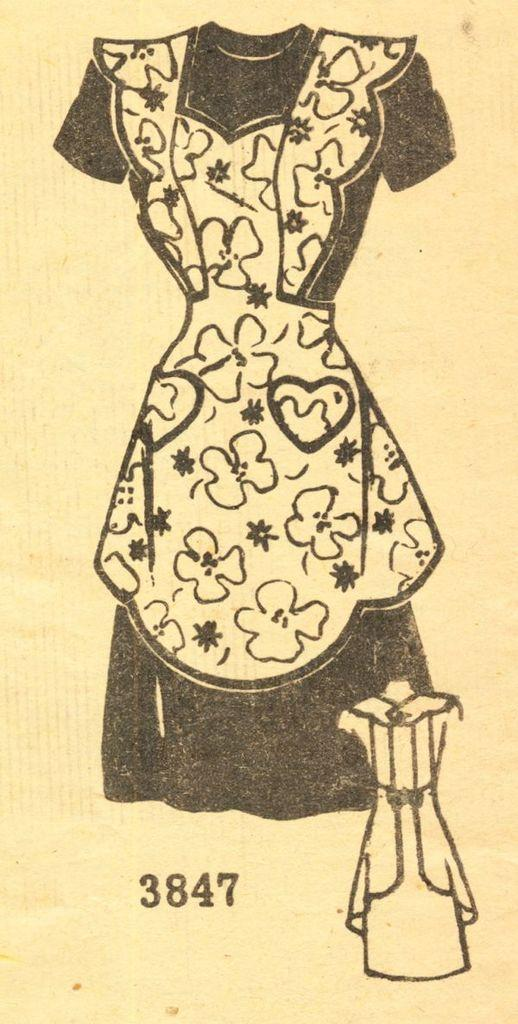What is the main subject of the image? The main subject of the image is a picture of a dress. Is there any additional information provided with the picture of the dress? Yes, there is a number below the picture of the dress. What type of pump can be seen next to the dress in the image? There is no pump present in the image; it only features a picture of a dress and a number below it. 